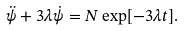Convert formula to latex. <formula><loc_0><loc_0><loc_500><loc_500>\ddot { \psi } + 3 \lambda \dot { \psi } = N \exp [ - 3 \lambda t ] .</formula> 